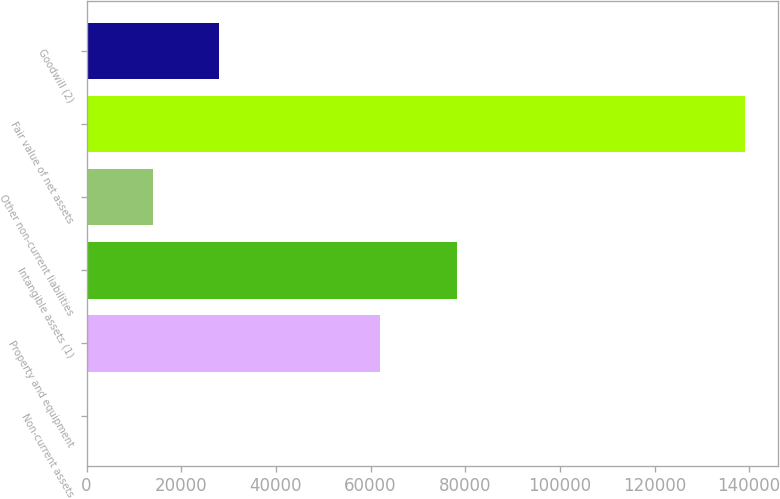Convert chart. <chart><loc_0><loc_0><loc_500><loc_500><bar_chart><fcel>Non-current assets<fcel>Property and equipment<fcel>Intangible assets (1)<fcel>Other non-current liabilities<fcel>Fair value of net assets<fcel>Goodwill (2)<nl><fcel>153<fcel>61995<fcel>78199<fcel>14041.4<fcel>139037<fcel>27929.8<nl></chart> 